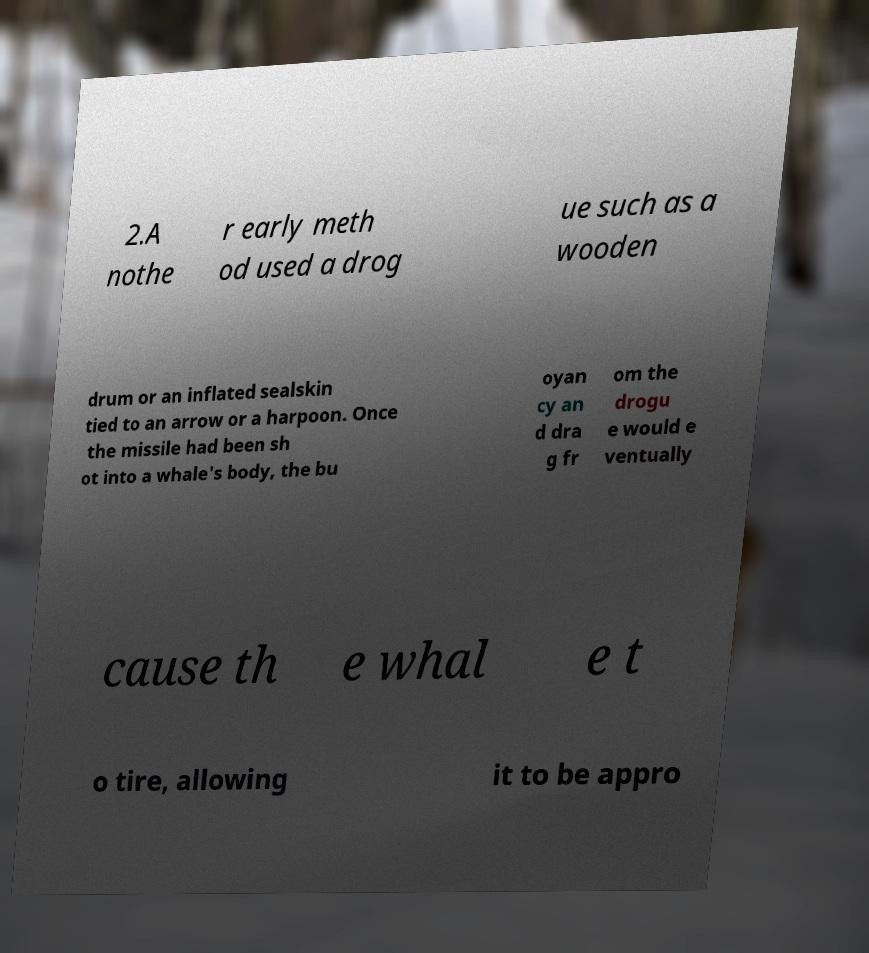I need the written content from this picture converted into text. Can you do that? 2.A nothe r early meth od used a drog ue such as a wooden drum or an inflated sealskin tied to an arrow or a harpoon. Once the missile had been sh ot into a whale's body, the bu oyan cy an d dra g fr om the drogu e would e ventually cause th e whal e t o tire, allowing it to be appro 